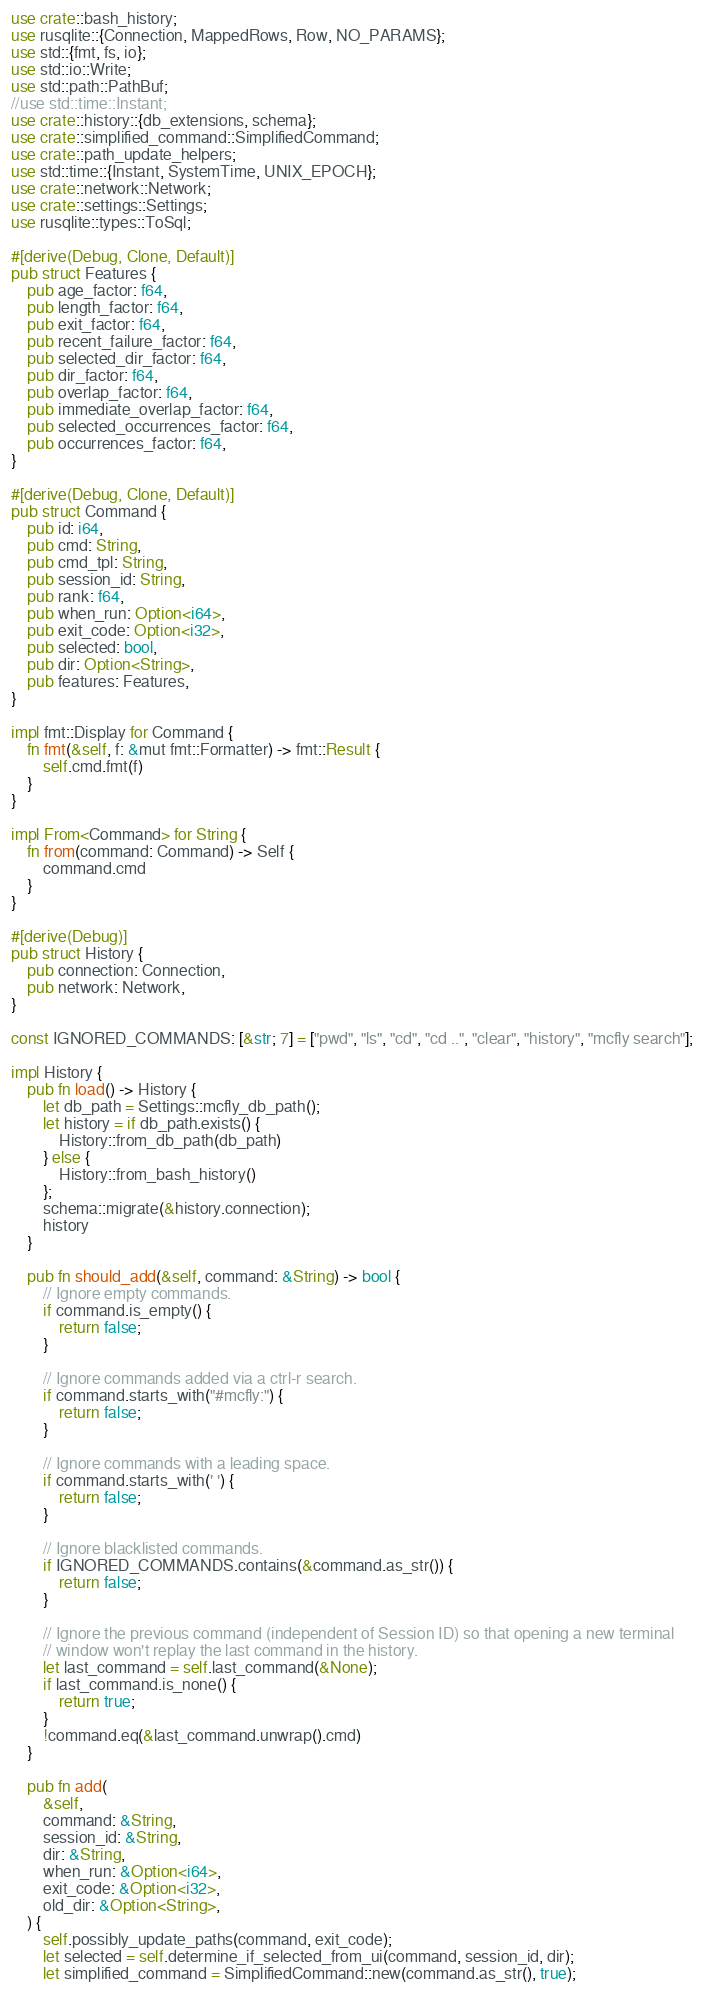Convert code to text. <code><loc_0><loc_0><loc_500><loc_500><_Rust_>use crate::bash_history;
use rusqlite::{Connection, MappedRows, Row, NO_PARAMS};
use std::{fmt, fs, io};
use std::io::Write;
use std::path::PathBuf;
//use std::time::Instant;
use crate::history::{db_extensions, schema};
use crate::simplified_command::SimplifiedCommand;
use crate::path_update_helpers;
use std::time::{Instant, SystemTime, UNIX_EPOCH};
use crate::network::Network;
use crate::settings::Settings;
use rusqlite::types::ToSql;

#[derive(Debug, Clone, Default)]
pub struct Features {
    pub age_factor: f64,
    pub length_factor: f64,
    pub exit_factor: f64,
    pub recent_failure_factor: f64,
    pub selected_dir_factor: f64,
    pub dir_factor: f64,
    pub overlap_factor: f64,
    pub immediate_overlap_factor: f64,
    pub selected_occurrences_factor: f64,
    pub occurrences_factor: f64,
}

#[derive(Debug, Clone, Default)]
pub struct Command {
    pub id: i64,
    pub cmd: String,
    pub cmd_tpl: String,
    pub session_id: String,
    pub rank: f64,
    pub when_run: Option<i64>,
    pub exit_code: Option<i32>,
    pub selected: bool,
    pub dir: Option<String>,
    pub features: Features,
}

impl fmt::Display for Command {
    fn fmt(&self, f: &mut fmt::Formatter) -> fmt::Result {
        self.cmd.fmt(f)
    }
}

impl From<Command> for String {
    fn from(command: Command) -> Self {
        command.cmd
    }
}

#[derive(Debug)]
pub struct History {
    pub connection: Connection,
    pub network: Network,
}

const IGNORED_COMMANDS: [&str; 7] = ["pwd", "ls", "cd", "cd ..", "clear", "history", "mcfly search"];

impl History {
    pub fn load() -> History {
        let db_path = Settings::mcfly_db_path();
        let history = if db_path.exists() {
            History::from_db_path(db_path)
        } else {
            History::from_bash_history()
        };
        schema::migrate(&history.connection);
        history
    }

    pub fn should_add(&self, command: &String) -> bool {
        // Ignore empty commands.
        if command.is_empty() {
            return false;
        }

        // Ignore commands added via a ctrl-r search.
        if command.starts_with("#mcfly:") {
            return false;
        }

        // Ignore commands with a leading space.
        if command.starts_with(' ') {
            return false;
        }

        // Ignore blacklisted commands.
        if IGNORED_COMMANDS.contains(&command.as_str()) {
            return false;
        }

        // Ignore the previous command (independent of Session ID) so that opening a new terminal
        // window won't replay the last command in the history.
        let last_command = self.last_command(&None);
        if last_command.is_none() {
            return true;
        }
        !command.eq(&last_command.unwrap().cmd)
    }

    pub fn add(
        &self,
        command: &String,
        session_id: &String,
        dir: &String,
        when_run: &Option<i64>,
        exit_code: &Option<i32>,
        old_dir: &Option<String>,
    ) {
        self.possibly_update_paths(command, exit_code);
        let selected = self.determine_if_selected_from_ui(command, session_id, dir);
        let simplified_command = SimplifiedCommand::new(command.as_str(), true);</code> 